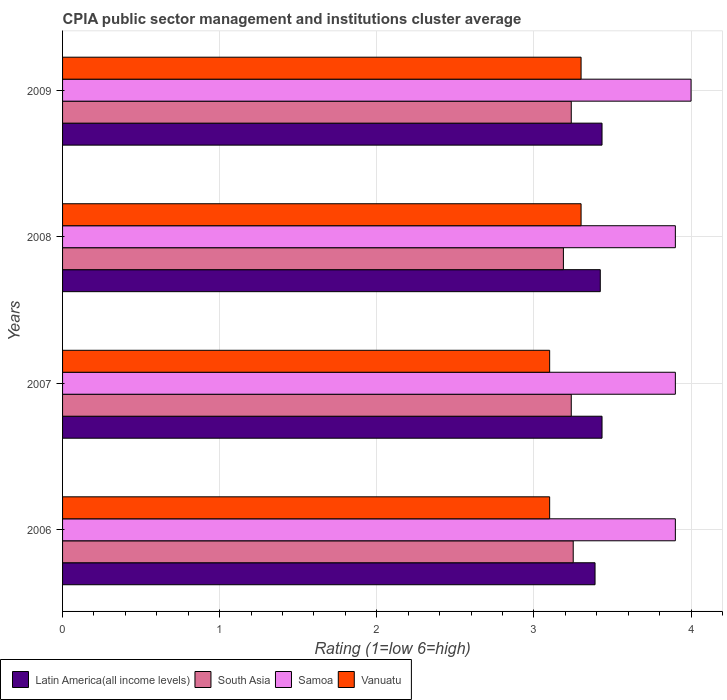How many different coloured bars are there?
Provide a succinct answer. 4. How many groups of bars are there?
Your answer should be compact. 4. Are the number of bars per tick equal to the number of legend labels?
Provide a succinct answer. Yes. Are the number of bars on each tick of the Y-axis equal?
Offer a very short reply. Yes. How many bars are there on the 4th tick from the bottom?
Keep it short and to the point. 4. In how many cases, is the number of bars for a given year not equal to the number of legend labels?
Provide a short and direct response. 0. What is the CPIA rating in South Asia in 2006?
Keep it short and to the point. 3.25. Across all years, what is the minimum CPIA rating in Latin America(all income levels)?
Keep it short and to the point. 3.39. In which year was the CPIA rating in Latin America(all income levels) minimum?
Your response must be concise. 2006. What is the total CPIA rating in Latin America(all income levels) in the graph?
Provide a short and direct response. 13.68. What is the difference between the CPIA rating in Vanuatu in 2006 and that in 2008?
Your response must be concise. -0.2. What is the difference between the CPIA rating in Samoa in 2006 and the CPIA rating in South Asia in 2008?
Offer a very short reply. 0.71. What is the average CPIA rating in Vanuatu per year?
Your answer should be compact. 3.2. In the year 2006, what is the difference between the CPIA rating in Samoa and CPIA rating in Vanuatu?
Provide a succinct answer. 0.8. In how many years, is the CPIA rating in South Asia greater than 1.4 ?
Ensure brevity in your answer.  4. What is the difference between the highest and the lowest CPIA rating in Samoa?
Your response must be concise. 0.1. Is it the case that in every year, the sum of the CPIA rating in South Asia and CPIA rating in Latin America(all income levels) is greater than the sum of CPIA rating in Samoa and CPIA rating in Vanuatu?
Provide a short and direct response. Yes. What does the 4th bar from the top in 2009 represents?
Ensure brevity in your answer.  Latin America(all income levels). What does the 4th bar from the bottom in 2007 represents?
Offer a terse response. Vanuatu. Are all the bars in the graph horizontal?
Provide a short and direct response. Yes. How many years are there in the graph?
Offer a terse response. 4. What is the difference between two consecutive major ticks on the X-axis?
Provide a short and direct response. 1. Where does the legend appear in the graph?
Offer a very short reply. Bottom left. How many legend labels are there?
Offer a very short reply. 4. What is the title of the graph?
Provide a succinct answer. CPIA public sector management and institutions cluster average. Does "Dominican Republic" appear as one of the legend labels in the graph?
Provide a short and direct response. No. What is the label or title of the Y-axis?
Give a very brief answer. Years. What is the Rating (1=low 6=high) of Latin America(all income levels) in 2006?
Offer a terse response. 3.39. What is the Rating (1=low 6=high) of South Asia in 2006?
Provide a succinct answer. 3.25. What is the Rating (1=low 6=high) in Vanuatu in 2006?
Your response must be concise. 3.1. What is the Rating (1=low 6=high) of Latin America(all income levels) in 2007?
Offer a very short reply. 3.43. What is the Rating (1=low 6=high) in South Asia in 2007?
Make the answer very short. 3.24. What is the Rating (1=low 6=high) in Latin America(all income levels) in 2008?
Provide a succinct answer. 3.42. What is the Rating (1=low 6=high) in South Asia in 2008?
Ensure brevity in your answer.  3.19. What is the Rating (1=low 6=high) in Samoa in 2008?
Offer a very short reply. 3.9. What is the Rating (1=low 6=high) in Latin America(all income levels) in 2009?
Your answer should be compact. 3.43. What is the Rating (1=low 6=high) of South Asia in 2009?
Provide a short and direct response. 3.24. What is the Rating (1=low 6=high) in Vanuatu in 2009?
Offer a very short reply. 3.3. Across all years, what is the maximum Rating (1=low 6=high) in Latin America(all income levels)?
Offer a terse response. 3.43. Across all years, what is the maximum Rating (1=low 6=high) of South Asia?
Give a very brief answer. 3.25. Across all years, what is the maximum Rating (1=low 6=high) in Samoa?
Offer a terse response. 4. Across all years, what is the minimum Rating (1=low 6=high) in Latin America(all income levels)?
Your response must be concise. 3.39. Across all years, what is the minimum Rating (1=low 6=high) in South Asia?
Offer a very short reply. 3.19. What is the total Rating (1=low 6=high) in Latin America(all income levels) in the graph?
Give a very brief answer. 13.68. What is the total Rating (1=low 6=high) of South Asia in the graph?
Provide a succinct answer. 12.91. What is the difference between the Rating (1=low 6=high) of Latin America(all income levels) in 2006 and that in 2007?
Offer a very short reply. -0.04. What is the difference between the Rating (1=low 6=high) in South Asia in 2006 and that in 2007?
Your answer should be compact. 0.01. What is the difference between the Rating (1=low 6=high) in Samoa in 2006 and that in 2007?
Offer a terse response. 0. What is the difference between the Rating (1=low 6=high) of Vanuatu in 2006 and that in 2007?
Your answer should be very brief. 0. What is the difference between the Rating (1=low 6=high) of Latin America(all income levels) in 2006 and that in 2008?
Provide a short and direct response. -0.03. What is the difference between the Rating (1=low 6=high) in South Asia in 2006 and that in 2008?
Ensure brevity in your answer.  0.06. What is the difference between the Rating (1=low 6=high) of Samoa in 2006 and that in 2008?
Make the answer very short. 0. What is the difference between the Rating (1=low 6=high) of Latin America(all income levels) in 2006 and that in 2009?
Give a very brief answer. -0.04. What is the difference between the Rating (1=low 6=high) of South Asia in 2006 and that in 2009?
Your answer should be compact. 0.01. What is the difference between the Rating (1=low 6=high) of Vanuatu in 2006 and that in 2009?
Offer a very short reply. -0.2. What is the difference between the Rating (1=low 6=high) of Latin America(all income levels) in 2007 and that in 2008?
Your response must be concise. 0.01. What is the difference between the Rating (1=low 6=high) in Vanuatu in 2007 and that in 2008?
Make the answer very short. -0.2. What is the difference between the Rating (1=low 6=high) in Latin America(all income levels) in 2007 and that in 2009?
Your response must be concise. 0. What is the difference between the Rating (1=low 6=high) in South Asia in 2007 and that in 2009?
Your response must be concise. 0. What is the difference between the Rating (1=low 6=high) of Latin America(all income levels) in 2008 and that in 2009?
Offer a terse response. -0.01. What is the difference between the Rating (1=low 6=high) in South Asia in 2008 and that in 2009?
Offer a very short reply. -0.05. What is the difference between the Rating (1=low 6=high) of Latin America(all income levels) in 2006 and the Rating (1=low 6=high) of South Asia in 2007?
Your answer should be compact. 0.15. What is the difference between the Rating (1=low 6=high) in Latin America(all income levels) in 2006 and the Rating (1=low 6=high) in Samoa in 2007?
Ensure brevity in your answer.  -0.51. What is the difference between the Rating (1=low 6=high) of Latin America(all income levels) in 2006 and the Rating (1=low 6=high) of Vanuatu in 2007?
Your answer should be compact. 0.29. What is the difference between the Rating (1=low 6=high) of South Asia in 2006 and the Rating (1=low 6=high) of Samoa in 2007?
Your response must be concise. -0.65. What is the difference between the Rating (1=low 6=high) in South Asia in 2006 and the Rating (1=low 6=high) in Vanuatu in 2007?
Make the answer very short. 0.15. What is the difference between the Rating (1=low 6=high) in Latin America(all income levels) in 2006 and the Rating (1=low 6=high) in South Asia in 2008?
Your response must be concise. 0.2. What is the difference between the Rating (1=low 6=high) of Latin America(all income levels) in 2006 and the Rating (1=low 6=high) of Samoa in 2008?
Keep it short and to the point. -0.51. What is the difference between the Rating (1=low 6=high) in Latin America(all income levels) in 2006 and the Rating (1=low 6=high) in Vanuatu in 2008?
Your response must be concise. 0.09. What is the difference between the Rating (1=low 6=high) in South Asia in 2006 and the Rating (1=low 6=high) in Samoa in 2008?
Provide a short and direct response. -0.65. What is the difference between the Rating (1=low 6=high) of Latin America(all income levels) in 2006 and the Rating (1=low 6=high) of South Asia in 2009?
Offer a very short reply. 0.15. What is the difference between the Rating (1=low 6=high) of Latin America(all income levels) in 2006 and the Rating (1=low 6=high) of Samoa in 2009?
Make the answer very short. -0.61. What is the difference between the Rating (1=low 6=high) in Latin America(all income levels) in 2006 and the Rating (1=low 6=high) in Vanuatu in 2009?
Provide a short and direct response. 0.09. What is the difference between the Rating (1=low 6=high) of South Asia in 2006 and the Rating (1=low 6=high) of Samoa in 2009?
Your answer should be compact. -0.75. What is the difference between the Rating (1=low 6=high) in South Asia in 2006 and the Rating (1=low 6=high) in Vanuatu in 2009?
Offer a terse response. -0.05. What is the difference between the Rating (1=low 6=high) of Samoa in 2006 and the Rating (1=low 6=high) of Vanuatu in 2009?
Provide a succinct answer. 0.6. What is the difference between the Rating (1=low 6=high) in Latin America(all income levels) in 2007 and the Rating (1=low 6=high) in South Asia in 2008?
Provide a succinct answer. 0.25. What is the difference between the Rating (1=low 6=high) in Latin America(all income levels) in 2007 and the Rating (1=low 6=high) in Samoa in 2008?
Provide a succinct answer. -0.47. What is the difference between the Rating (1=low 6=high) in Latin America(all income levels) in 2007 and the Rating (1=low 6=high) in Vanuatu in 2008?
Your answer should be compact. 0.13. What is the difference between the Rating (1=low 6=high) in South Asia in 2007 and the Rating (1=low 6=high) in Samoa in 2008?
Keep it short and to the point. -0.66. What is the difference between the Rating (1=low 6=high) of South Asia in 2007 and the Rating (1=low 6=high) of Vanuatu in 2008?
Make the answer very short. -0.06. What is the difference between the Rating (1=low 6=high) of Samoa in 2007 and the Rating (1=low 6=high) of Vanuatu in 2008?
Give a very brief answer. 0.6. What is the difference between the Rating (1=low 6=high) of Latin America(all income levels) in 2007 and the Rating (1=low 6=high) of South Asia in 2009?
Give a very brief answer. 0.2. What is the difference between the Rating (1=low 6=high) of Latin America(all income levels) in 2007 and the Rating (1=low 6=high) of Samoa in 2009?
Ensure brevity in your answer.  -0.57. What is the difference between the Rating (1=low 6=high) in Latin America(all income levels) in 2007 and the Rating (1=low 6=high) in Vanuatu in 2009?
Offer a very short reply. 0.13. What is the difference between the Rating (1=low 6=high) of South Asia in 2007 and the Rating (1=low 6=high) of Samoa in 2009?
Provide a short and direct response. -0.76. What is the difference between the Rating (1=low 6=high) of South Asia in 2007 and the Rating (1=low 6=high) of Vanuatu in 2009?
Your response must be concise. -0.06. What is the difference between the Rating (1=low 6=high) of Latin America(all income levels) in 2008 and the Rating (1=low 6=high) of South Asia in 2009?
Your response must be concise. 0.18. What is the difference between the Rating (1=low 6=high) in Latin America(all income levels) in 2008 and the Rating (1=low 6=high) in Samoa in 2009?
Give a very brief answer. -0.58. What is the difference between the Rating (1=low 6=high) in Latin America(all income levels) in 2008 and the Rating (1=low 6=high) in Vanuatu in 2009?
Keep it short and to the point. 0.12. What is the difference between the Rating (1=low 6=high) in South Asia in 2008 and the Rating (1=low 6=high) in Samoa in 2009?
Provide a short and direct response. -0.81. What is the difference between the Rating (1=low 6=high) in South Asia in 2008 and the Rating (1=low 6=high) in Vanuatu in 2009?
Offer a very short reply. -0.11. What is the difference between the Rating (1=low 6=high) in Samoa in 2008 and the Rating (1=low 6=high) in Vanuatu in 2009?
Your answer should be very brief. 0.6. What is the average Rating (1=low 6=high) in Latin America(all income levels) per year?
Your answer should be very brief. 3.42. What is the average Rating (1=low 6=high) in South Asia per year?
Your answer should be very brief. 3.23. What is the average Rating (1=low 6=high) of Samoa per year?
Make the answer very short. 3.92. What is the average Rating (1=low 6=high) in Vanuatu per year?
Your answer should be compact. 3.2. In the year 2006, what is the difference between the Rating (1=low 6=high) of Latin America(all income levels) and Rating (1=low 6=high) of South Asia?
Your response must be concise. 0.14. In the year 2006, what is the difference between the Rating (1=low 6=high) of Latin America(all income levels) and Rating (1=low 6=high) of Samoa?
Give a very brief answer. -0.51. In the year 2006, what is the difference between the Rating (1=low 6=high) in Latin America(all income levels) and Rating (1=low 6=high) in Vanuatu?
Ensure brevity in your answer.  0.29. In the year 2006, what is the difference between the Rating (1=low 6=high) in South Asia and Rating (1=low 6=high) in Samoa?
Your answer should be very brief. -0.65. In the year 2006, what is the difference between the Rating (1=low 6=high) of Samoa and Rating (1=low 6=high) of Vanuatu?
Provide a short and direct response. 0.8. In the year 2007, what is the difference between the Rating (1=low 6=high) of Latin America(all income levels) and Rating (1=low 6=high) of South Asia?
Keep it short and to the point. 0.2. In the year 2007, what is the difference between the Rating (1=low 6=high) in Latin America(all income levels) and Rating (1=low 6=high) in Samoa?
Provide a succinct answer. -0.47. In the year 2007, what is the difference between the Rating (1=low 6=high) of Latin America(all income levels) and Rating (1=low 6=high) of Vanuatu?
Your answer should be compact. 0.33. In the year 2007, what is the difference between the Rating (1=low 6=high) in South Asia and Rating (1=low 6=high) in Samoa?
Ensure brevity in your answer.  -0.66. In the year 2007, what is the difference between the Rating (1=low 6=high) of South Asia and Rating (1=low 6=high) of Vanuatu?
Your answer should be very brief. 0.14. In the year 2007, what is the difference between the Rating (1=low 6=high) in Samoa and Rating (1=low 6=high) in Vanuatu?
Your answer should be compact. 0.8. In the year 2008, what is the difference between the Rating (1=low 6=high) of Latin America(all income levels) and Rating (1=low 6=high) of South Asia?
Offer a terse response. 0.23. In the year 2008, what is the difference between the Rating (1=low 6=high) in Latin America(all income levels) and Rating (1=low 6=high) in Samoa?
Offer a very short reply. -0.48. In the year 2008, what is the difference between the Rating (1=low 6=high) of Latin America(all income levels) and Rating (1=low 6=high) of Vanuatu?
Offer a terse response. 0.12. In the year 2008, what is the difference between the Rating (1=low 6=high) of South Asia and Rating (1=low 6=high) of Samoa?
Make the answer very short. -0.71. In the year 2008, what is the difference between the Rating (1=low 6=high) in South Asia and Rating (1=low 6=high) in Vanuatu?
Your answer should be very brief. -0.11. In the year 2008, what is the difference between the Rating (1=low 6=high) in Samoa and Rating (1=low 6=high) in Vanuatu?
Keep it short and to the point. 0.6. In the year 2009, what is the difference between the Rating (1=low 6=high) in Latin America(all income levels) and Rating (1=low 6=high) in South Asia?
Give a very brief answer. 0.2. In the year 2009, what is the difference between the Rating (1=low 6=high) of Latin America(all income levels) and Rating (1=low 6=high) of Samoa?
Give a very brief answer. -0.57. In the year 2009, what is the difference between the Rating (1=low 6=high) in Latin America(all income levels) and Rating (1=low 6=high) in Vanuatu?
Offer a very short reply. 0.13. In the year 2009, what is the difference between the Rating (1=low 6=high) of South Asia and Rating (1=low 6=high) of Samoa?
Offer a very short reply. -0.76. In the year 2009, what is the difference between the Rating (1=low 6=high) in South Asia and Rating (1=low 6=high) in Vanuatu?
Provide a succinct answer. -0.06. In the year 2009, what is the difference between the Rating (1=low 6=high) in Samoa and Rating (1=low 6=high) in Vanuatu?
Offer a terse response. 0.7. What is the ratio of the Rating (1=low 6=high) of Latin America(all income levels) in 2006 to that in 2007?
Provide a short and direct response. 0.99. What is the ratio of the Rating (1=low 6=high) in South Asia in 2006 to that in 2007?
Ensure brevity in your answer.  1. What is the ratio of the Rating (1=low 6=high) in Latin America(all income levels) in 2006 to that in 2008?
Offer a very short reply. 0.99. What is the ratio of the Rating (1=low 6=high) of South Asia in 2006 to that in 2008?
Make the answer very short. 1.02. What is the ratio of the Rating (1=low 6=high) of Samoa in 2006 to that in 2008?
Your answer should be very brief. 1. What is the ratio of the Rating (1=low 6=high) of Vanuatu in 2006 to that in 2008?
Your answer should be very brief. 0.94. What is the ratio of the Rating (1=low 6=high) of Latin America(all income levels) in 2006 to that in 2009?
Offer a terse response. 0.99. What is the ratio of the Rating (1=low 6=high) in Vanuatu in 2006 to that in 2009?
Give a very brief answer. 0.94. What is the ratio of the Rating (1=low 6=high) of Latin America(all income levels) in 2007 to that in 2008?
Your answer should be very brief. 1. What is the ratio of the Rating (1=low 6=high) in South Asia in 2007 to that in 2008?
Give a very brief answer. 1.02. What is the ratio of the Rating (1=low 6=high) in Vanuatu in 2007 to that in 2008?
Keep it short and to the point. 0.94. What is the ratio of the Rating (1=low 6=high) in Samoa in 2007 to that in 2009?
Your answer should be very brief. 0.97. What is the ratio of the Rating (1=low 6=high) of Vanuatu in 2007 to that in 2009?
Offer a terse response. 0.94. What is the ratio of the Rating (1=low 6=high) in Latin America(all income levels) in 2008 to that in 2009?
Your response must be concise. 1. What is the ratio of the Rating (1=low 6=high) of South Asia in 2008 to that in 2009?
Ensure brevity in your answer.  0.98. What is the difference between the highest and the second highest Rating (1=low 6=high) in South Asia?
Offer a very short reply. 0.01. What is the difference between the highest and the second highest Rating (1=low 6=high) of Vanuatu?
Offer a very short reply. 0. What is the difference between the highest and the lowest Rating (1=low 6=high) of Latin America(all income levels)?
Ensure brevity in your answer.  0.04. What is the difference between the highest and the lowest Rating (1=low 6=high) in South Asia?
Give a very brief answer. 0.06. 